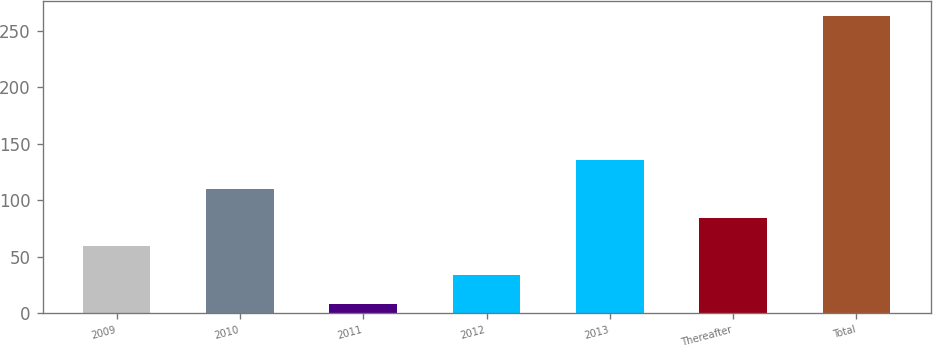Convert chart to OTSL. <chart><loc_0><loc_0><loc_500><loc_500><bar_chart><fcel>2009<fcel>2010<fcel>2011<fcel>2012<fcel>2013<fcel>Thereafter<fcel>Total<nl><fcel>59<fcel>110<fcel>8<fcel>33.5<fcel>135.5<fcel>84.5<fcel>263<nl></chart> 